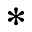Convert formula to latex. <formula><loc_0><loc_0><loc_500><loc_500>^ { * }</formula> 